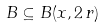<formula> <loc_0><loc_0><loc_500><loc_500>B \subseteq B ( x , 2 \, r )</formula> 